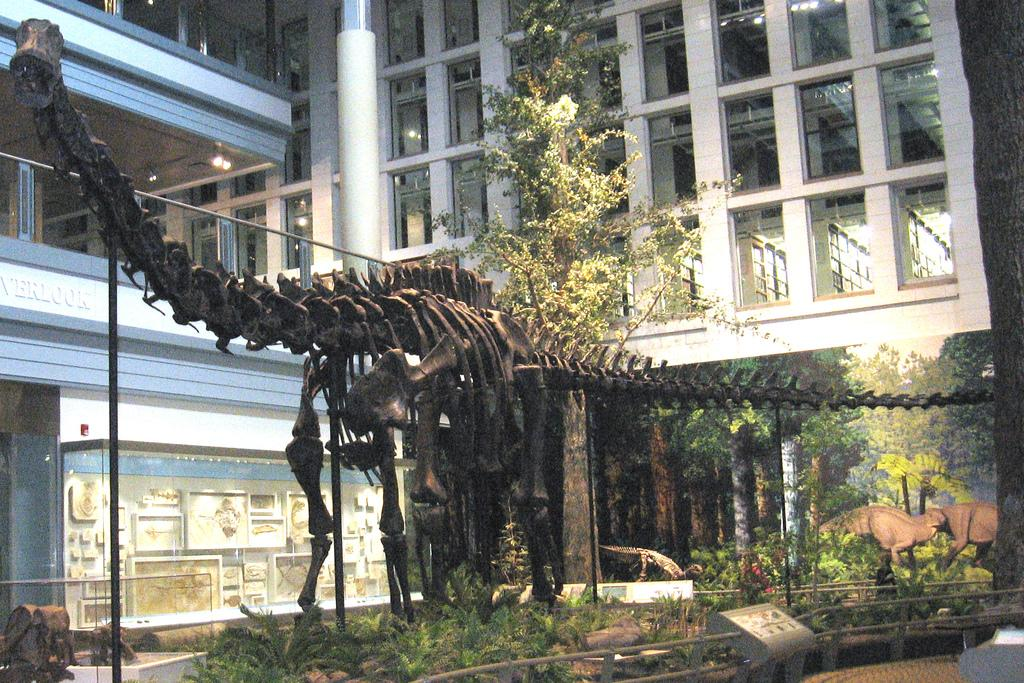What can be seen on the ground in the image? There is a skeleton of an animal on the ground. What type of natural elements are present in the image? There are plants and trees in the image. What living organisms can be seen in the image? There are animals in the image. What man-made objects are visible in the image? There are objects in the image. What can be seen in the background of the image? There is a building and lights in the background. Where is the sofa located in the image? There is no sofa present in the image. What type of vehicle can be seen driving in the image? There is no vehicle or driving activity depicted in the image. 